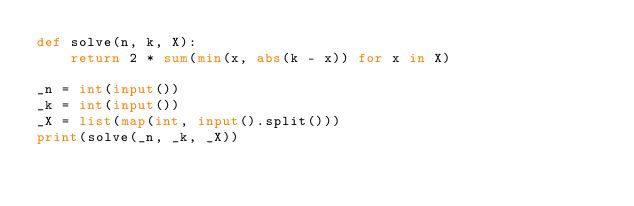<code> <loc_0><loc_0><loc_500><loc_500><_Python_>def solve(n, k, X):
    return 2 * sum(min(x, abs(k - x)) for x in X)

_n = int(input())
_k = int(input())
_X = list(map(int, input().split()))
print(solve(_n, _k, _X))</code> 